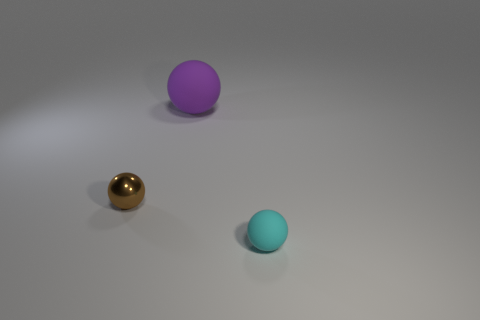Do the big ball and the tiny shiny thing have the same color?
Provide a succinct answer. No. Does the big ball have the same material as the small cyan sphere?
Your response must be concise. Yes. Is the big rubber thing the same shape as the cyan rubber thing?
Give a very brief answer. Yes. Are there the same number of large purple matte things in front of the big ball and large rubber objects that are in front of the tiny brown thing?
Keep it short and to the point. Yes. There is another thing that is the same material as the small cyan thing; what is its color?
Your answer should be compact. Purple. What number of other things are made of the same material as the cyan object?
Provide a succinct answer. 1. Do the matte thing in front of the big rubber object and the big rubber ball have the same color?
Offer a very short reply. No. What number of other cyan rubber things have the same shape as the small rubber object?
Offer a terse response. 0. Are there the same number of large purple balls that are to the left of the small matte thing and large gray cubes?
Make the answer very short. No. The thing that is the same size as the metallic ball is what color?
Keep it short and to the point. Cyan. 